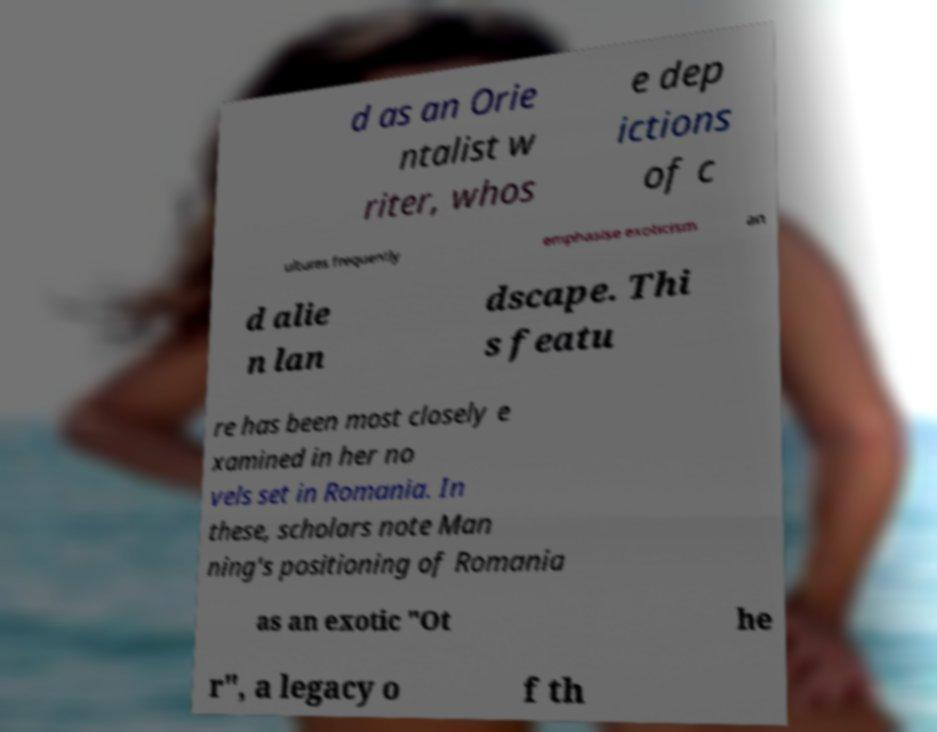There's text embedded in this image that I need extracted. Can you transcribe it verbatim? d as an Orie ntalist w riter, whos e dep ictions of c ultures frequently emphasise exoticism an d alie n lan dscape. Thi s featu re has been most closely e xamined in her no vels set in Romania. In these, scholars note Man ning's positioning of Romania as an exotic "Ot he r", a legacy o f th 